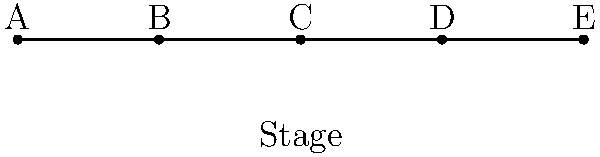Your favorite indie rock band, "The Sonic Rebels," has 5 members (A, B, C, D, and E) who like to switch positions on stage for different songs. How many unique ways can they arrange themselves in a line across the stage? Let's approach this step-by-step:

1. This is a permutation problem. We need to arrange 5 distinct band members in a line.

2. For the first position, we have 5 choices (any of the 5 band members can go first).

3. After placing the first member, we have 4 choices for the second position.

4. For the third position, we'll have 3 choices left.

5. For the fourth position, we'll have 2 choices.

6. For the last position, we'll only have 1 choice left (the last remaining band member).

7. According to the multiplication principle, we multiply these numbers together:

   $$5 \times 4 \times 3 \times 2 \times 1 = 120$$

8. This is also known as 5 factorial, written as $5!$.

Therefore, there are 120 unique ways for the band members to arrange themselves on stage.
Answer: 120 